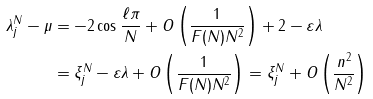<formula> <loc_0><loc_0><loc_500><loc_500>\lambda ^ { N } _ { j } - \mu & = - 2 \cos \frac { \ell \pi } { N } + O \left ( \frac { 1 } { F ( N ) N ^ { 2 } } \right ) + 2 - \varepsilon \lambda \\ & = \xi ^ { N } _ { j } - \varepsilon \lambda + O \left ( \frac { 1 } { F ( N ) N ^ { 2 } } \right ) = \xi ^ { N } _ { j } + O \left ( \frac { n ^ { 2 } } { N ^ { 2 } } \right )</formula> 